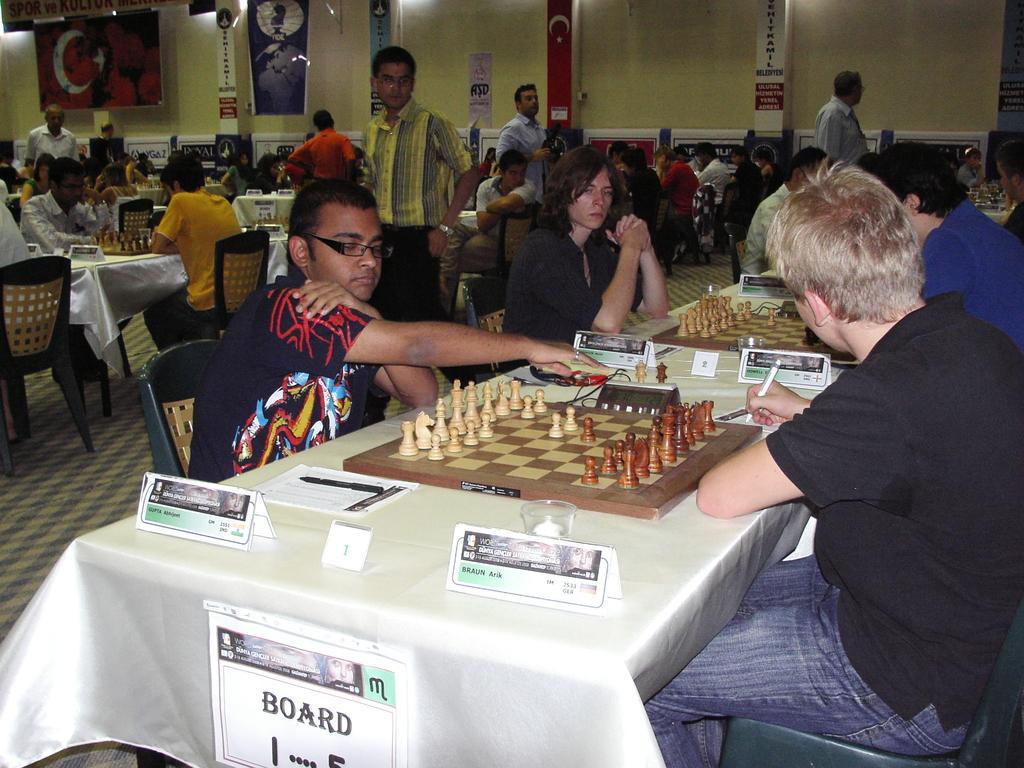Describe this image in one or two sentences. There are two persons sitting and playing chess. On the right hand side of the table, the person is writing something on the table. On the left hand side of the table, the person is tapping something on the table. There are name boards and some objects on the table. This sign board is attached with the table. Beside these persons, there are other players. They are playing chess. There are six people standing and watching these players. In the background, there is a wall, light, poster and hoarding. 